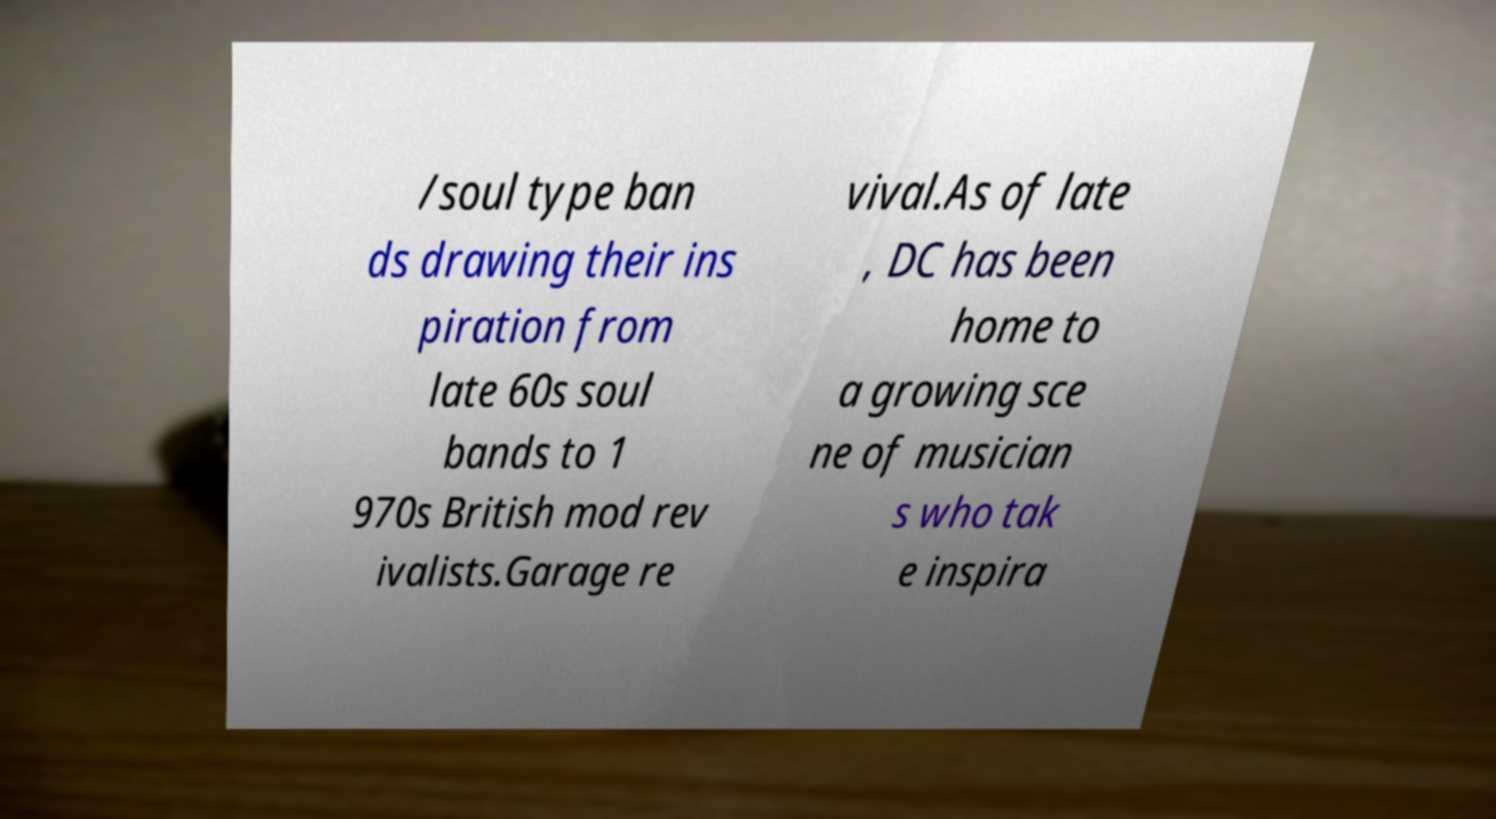Can you accurately transcribe the text from the provided image for me? /soul type ban ds drawing their ins piration from late 60s soul bands to 1 970s British mod rev ivalists.Garage re vival.As of late , DC has been home to a growing sce ne of musician s who tak e inspira 